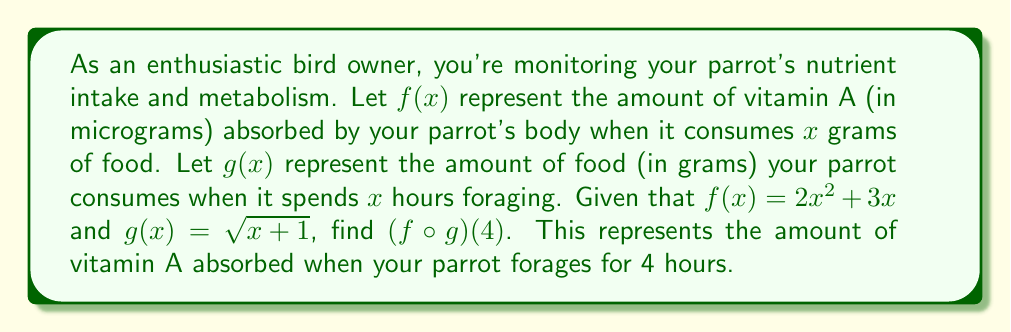Give your solution to this math problem. To solve this problem, we need to find the composition of functions $f$ and $g$, then evaluate it at $x = 4$. Let's break it down step-by-step:

1) The composition $(f \circ g)(x)$ means we apply function $g$ first, then function $f$ to the result.

2) We start by finding $g(4)$:
   $g(4) = \sqrt{4 + 1} = \sqrt{5}$

3) Now we need to find $f(\sqrt{5})$:
   $f(x) = 2x^2 + 3x$
   So, $f(\sqrt{5}) = 2(\sqrt{5})^2 + 3(\sqrt{5})$

4) Let's simplify this:
   $f(\sqrt{5}) = 2(5) + 3(\sqrt{5})$
   $f(\sqrt{5}) = 10 + 3\sqrt{5}$

5) Therefore, $(f \circ g)(4) = 10 + 3\sqrt{5}$

This result represents the amount of vitamin A (in micrograms) absorbed by your parrot when it forages for 4 hours.
Answer: $(f \circ g)(4) = 10 + 3\sqrt{5}$ micrograms of vitamin A 